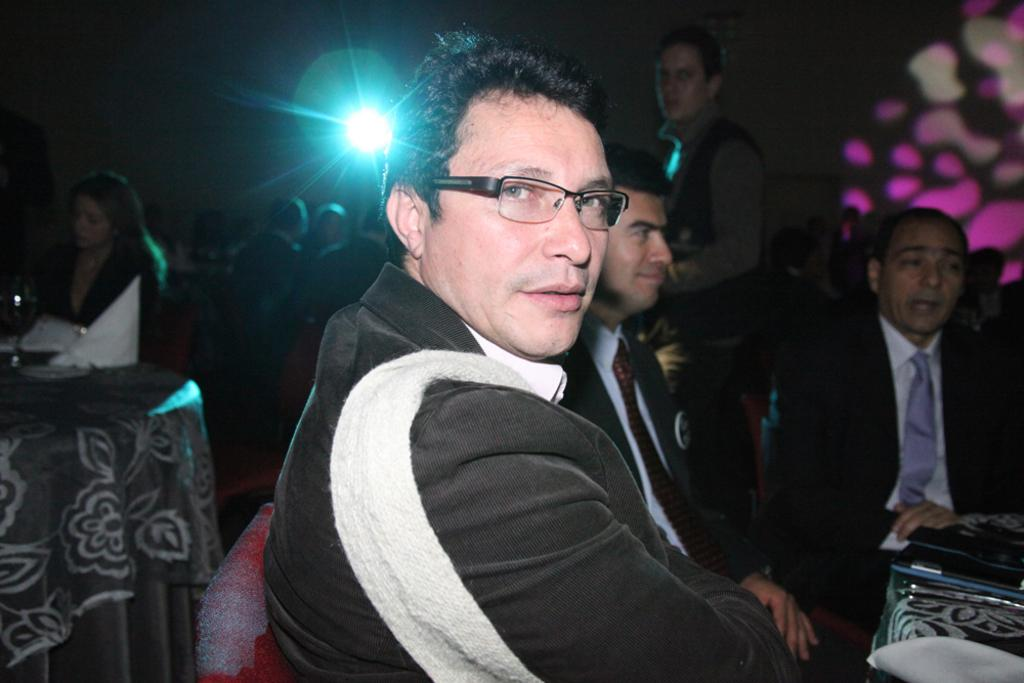What are the people in the image doing? There is a group of people sitting on chairs in the image. Are there any other people in the image besides those sitting? Yes, there is a person standing in the image. What can be seen on the tables in the image? There are objects on the tables in the image. What can be seen in the background of the image? There is a light visible in the background of the image. What color is the cherry that the person is holding in the image? There is no cherry present in the image. What type of spark can be seen coming from the light in the background? There is no spark visible in the image; only a light is present in the background. 